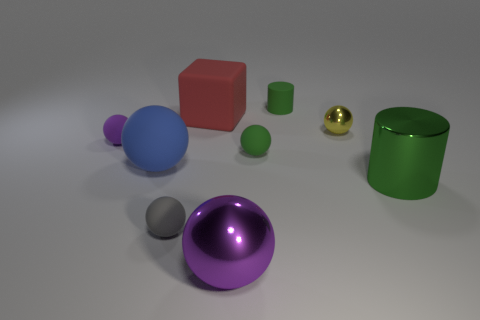Are there fewer large metal things on the left side of the gray ball than blue blocks?
Your response must be concise. No. There is a cube that is the same size as the blue matte ball; what color is it?
Offer a terse response. Red. What number of large purple things have the same shape as the red object?
Your answer should be very brief. 0. What color is the cylinder in front of the small green matte cylinder?
Your answer should be compact. Green. How many rubber things are big green objects or small spheres?
Ensure brevity in your answer.  3. What is the shape of the small thing that is the same color as the big metal ball?
Make the answer very short. Sphere. What number of yellow balls have the same size as the purple rubber sphere?
Offer a terse response. 1. What is the color of the big object that is in front of the blue rubber ball and to the left of the green metal cylinder?
Provide a short and direct response. Purple. What number of objects are large blue rubber cubes or gray spheres?
Your answer should be compact. 1. What number of large objects are green matte spheres or rubber blocks?
Your response must be concise. 1. 